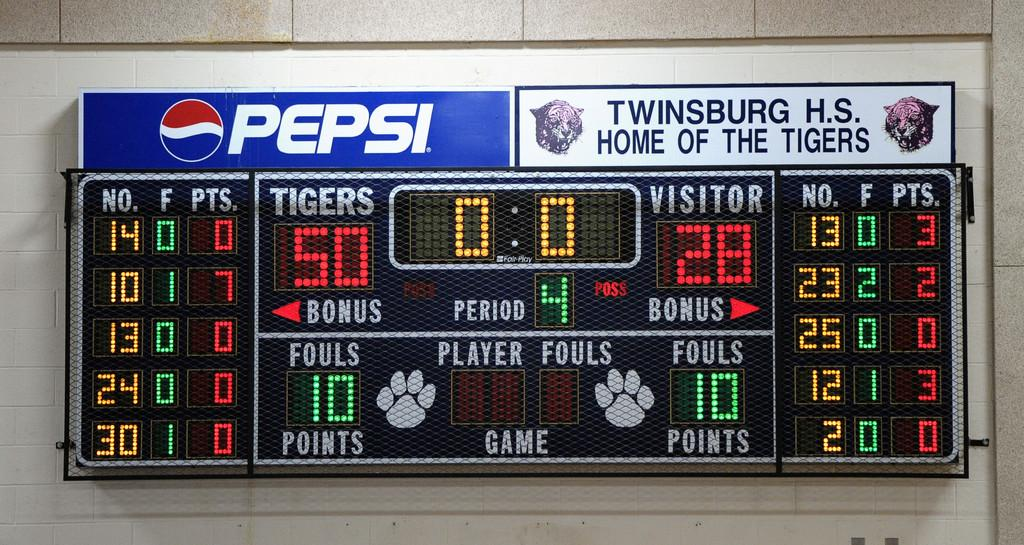<image>
Share a concise interpretation of the image provided. Scoreboard for Twinsburg High School sponsored by Pepsi. 